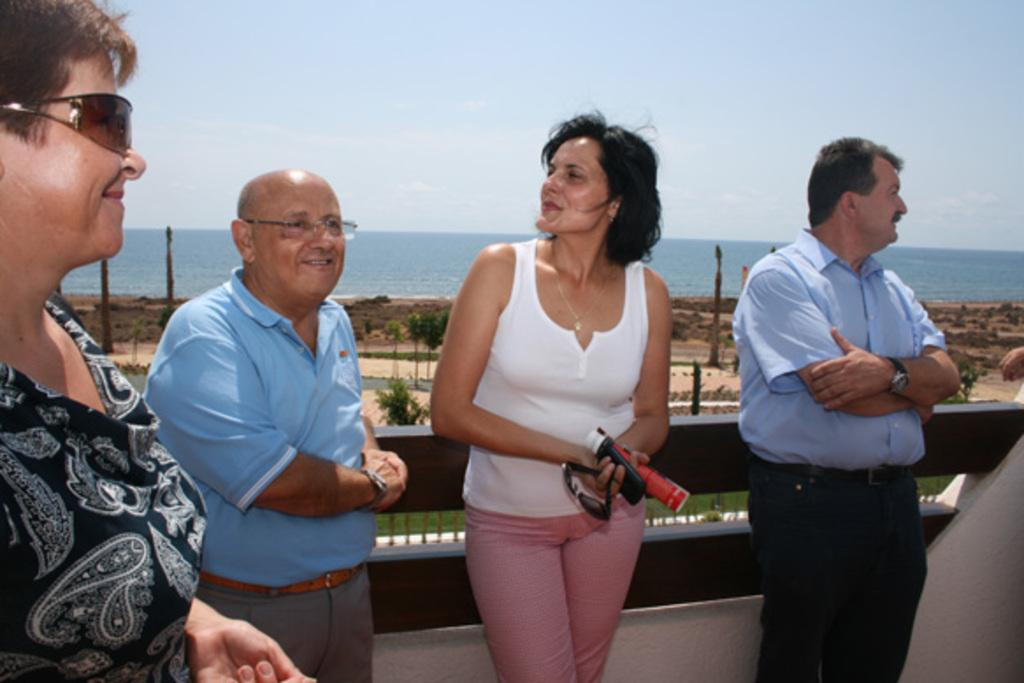What can be seen in the background of the image? Sky and sea are visible in the background of the image. What type of vegetation is present in the image? Plants and grass are present in the image. Are there any people in the image? Yes, there are people standing in the image. What is the woman holding in her hands? The woman is holding a mobile, a bottle, and goggles in her hands. What type of polish is the woman applying to her nails in the image? There is no indication in the image that the woman is applying any polish to her nails. What type of paper is the woman holding in her hands? The woman is not holding any paper in her hands; she is holding a mobile, a bottle, and goggles. 